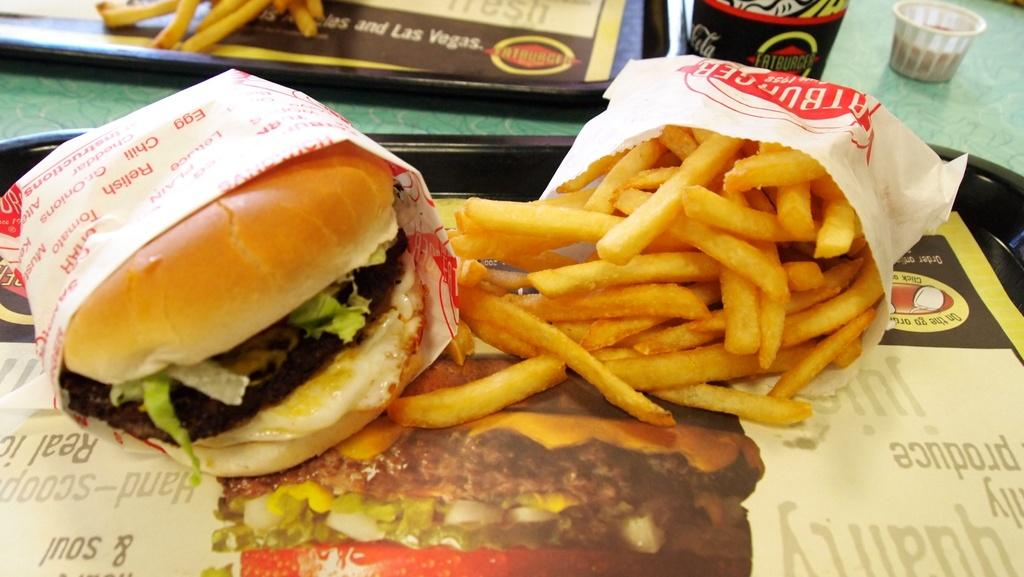What piece of furniture is visible in the image? There is a table in the image. How many trays are on the table? There are two trays on the table. What is placed in one of the trays? There is a burger in one of the trays. What is placed in the other tray? French fries are in the other tray. Is there any text visible on the trays? Yes, there is some text on one of the trays. What type of skin can be seen on the burger in the image? There is no skin visible on the burger in the image; it is a cooked patty. How does the taste of the burger compare to the taste of the French fries in the image? The image does not provide any information about the taste of the burger or French fries, as it is a still image and cannot convey taste. 